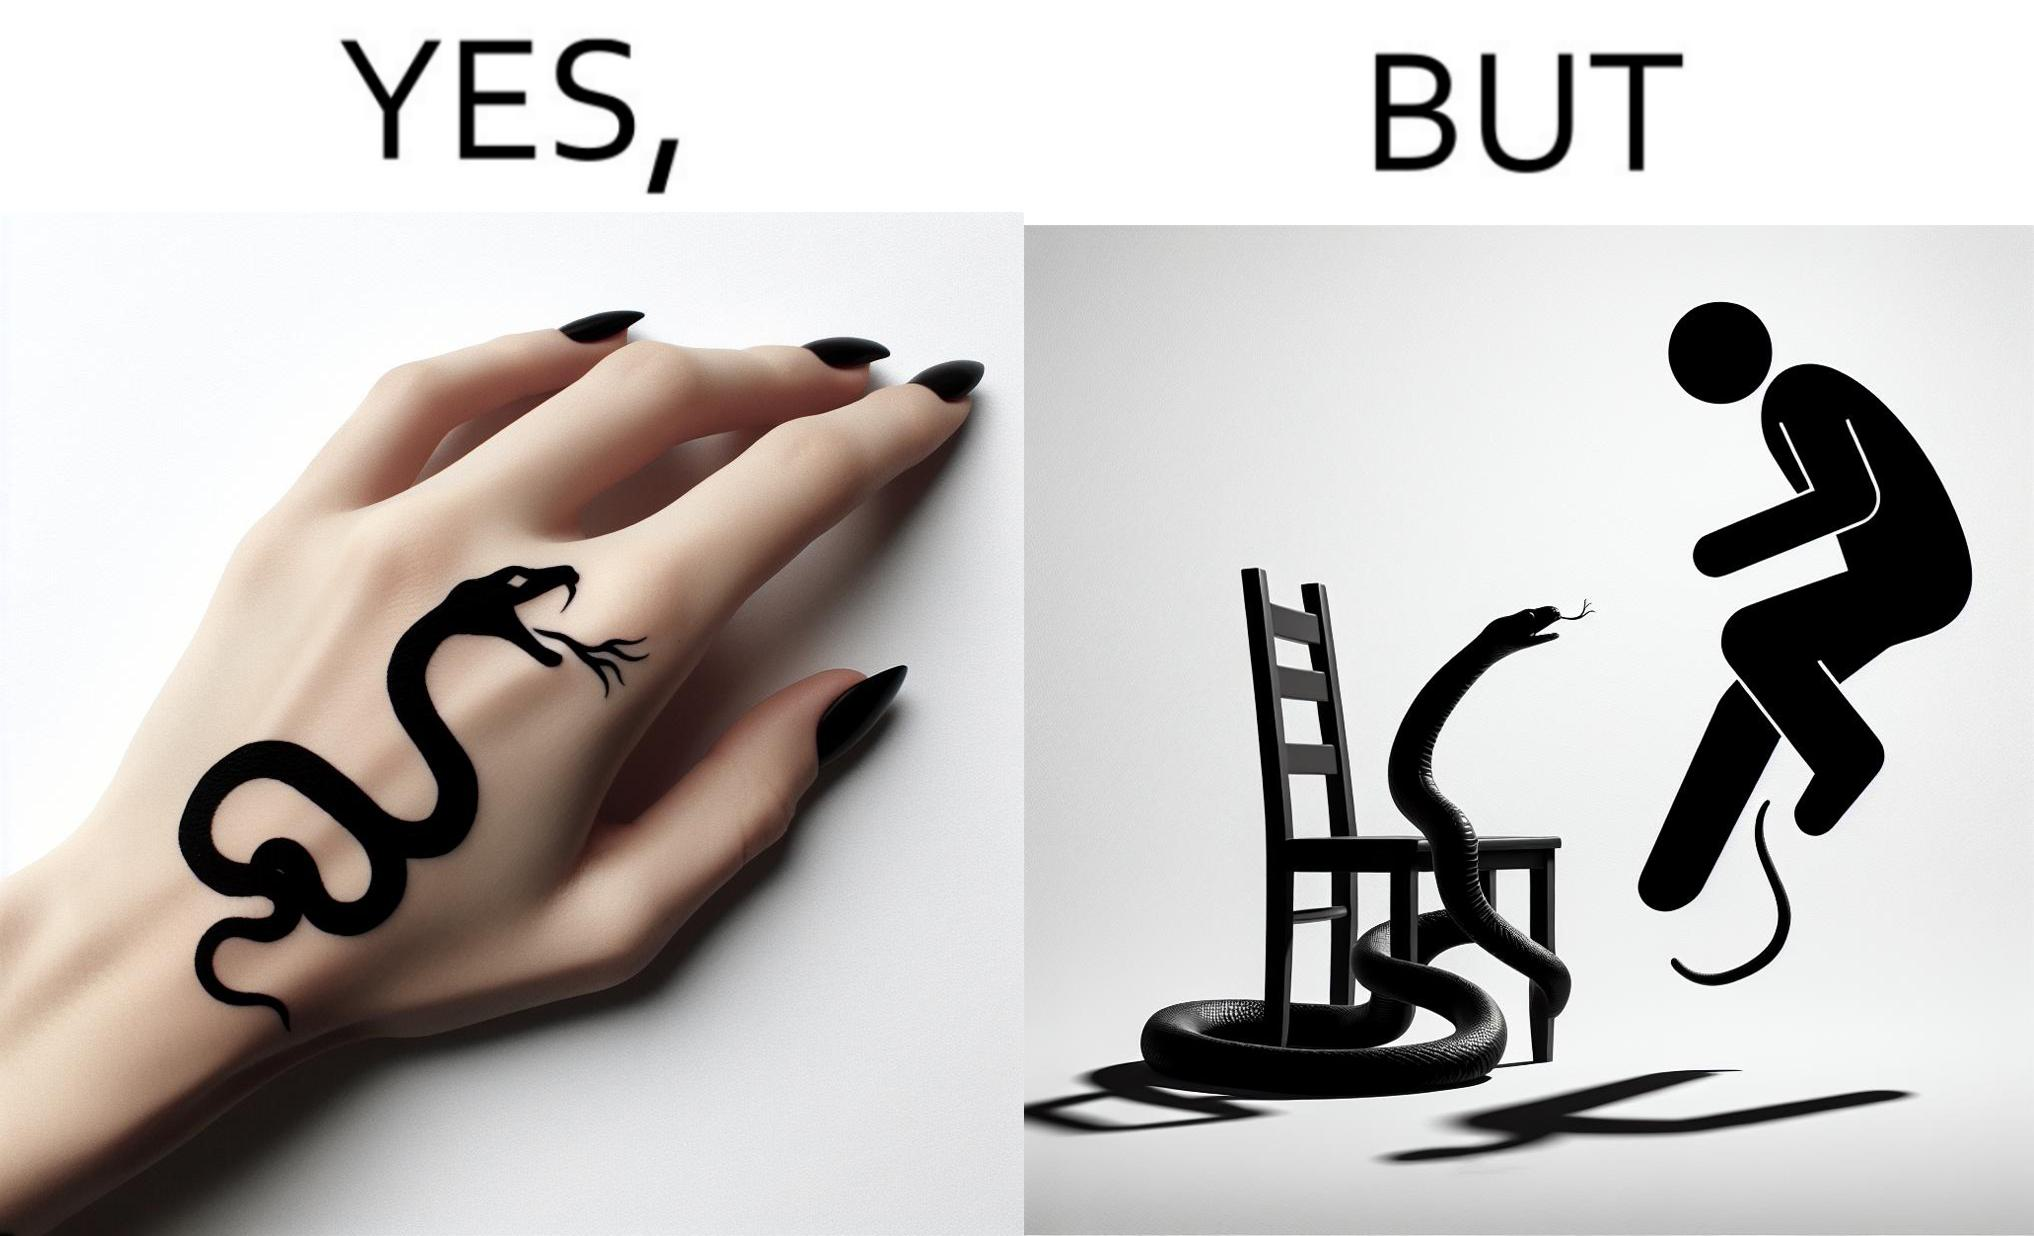Compare the left and right sides of this image. In the left part of the image: a tattoo of a snake with its mouth wide open on someone's hand In the right part of the image: a person standing on a chair trying save himself from the attack of snake and the snake is probably trying to climb up the chair 